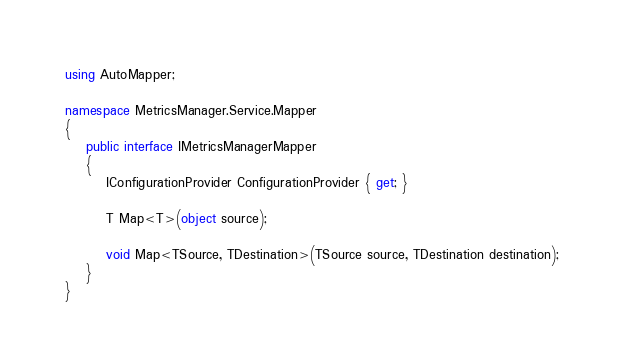<code> <loc_0><loc_0><loc_500><loc_500><_C#_>using AutoMapper;

namespace MetricsManager.Service.Mapper
{
    public interface IMetricsManagerMapper
    {
        IConfigurationProvider ConfigurationProvider { get; }

        T Map<T>(object source);

        void Map<TSource, TDestination>(TSource source, TDestination destination);
    }
}</code> 